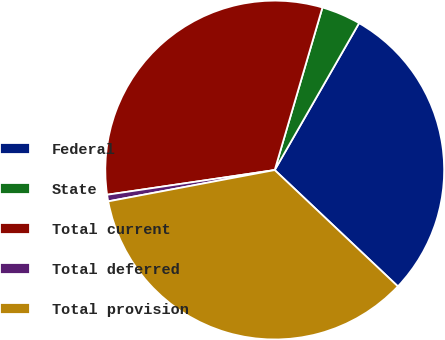Convert chart to OTSL. <chart><loc_0><loc_0><loc_500><loc_500><pie_chart><fcel>Federal<fcel>State<fcel>Total current<fcel>Total deferred<fcel>Total provision<nl><fcel>28.75%<fcel>3.75%<fcel>31.87%<fcel>0.63%<fcel>34.99%<nl></chart> 